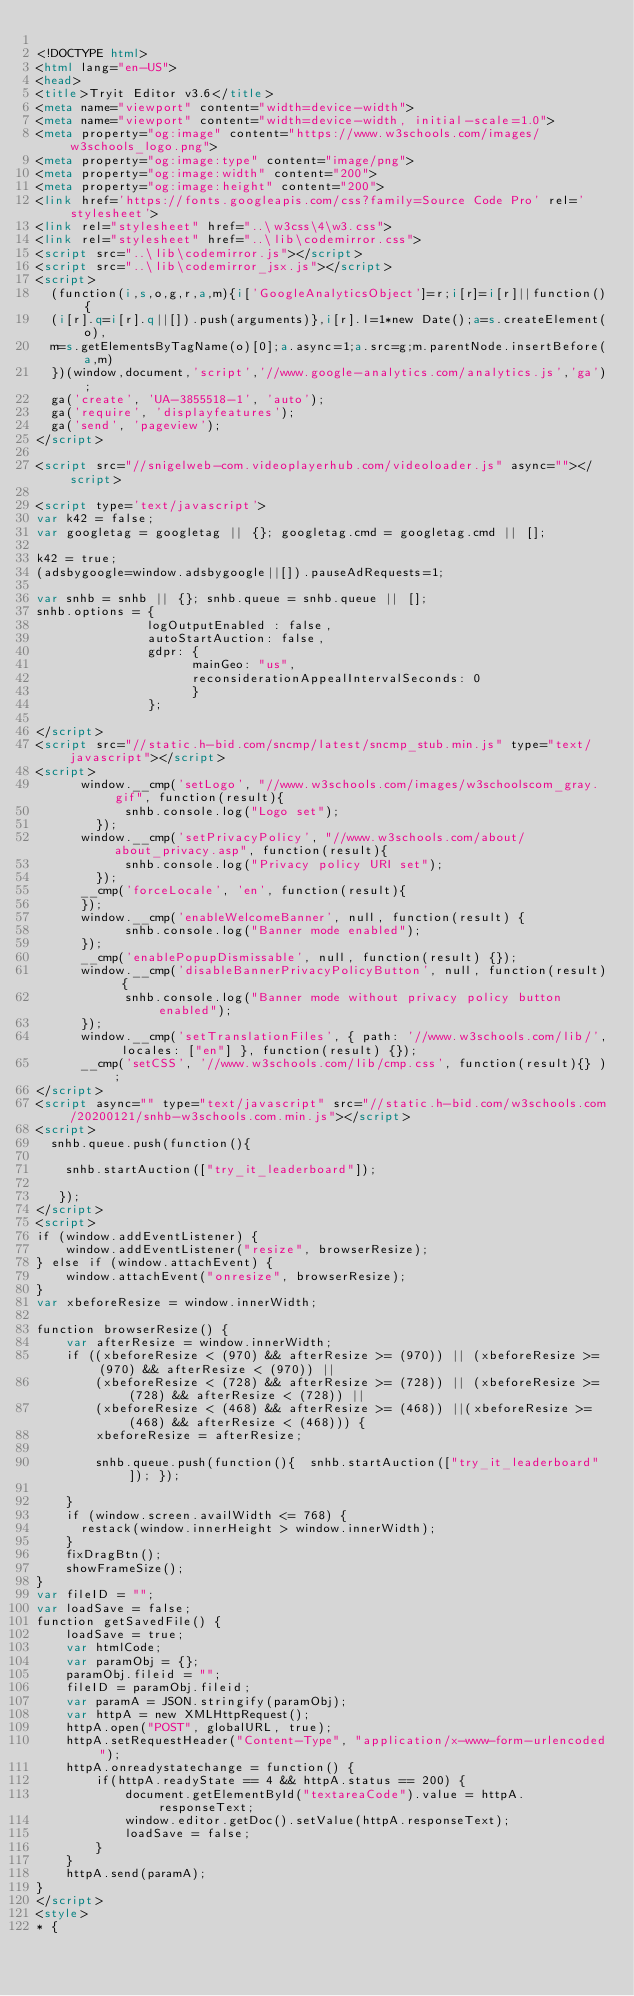<code> <loc_0><loc_0><loc_500><loc_500><_HTML_>
<!DOCTYPE html>
<html lang="en-US">
<head>
<title>Tryit Editor v3.6</title>
<meta name="viewport" content="width=device-width">
<meta name="viewport" content="width=device-width, initial-scale=1.0">
<meta property="og:image" content="https://www.w3schools.com/images/w3schools_logo.png">
<meta property="og:image:type" content="image/png">
<meta property="og:image:width" content="200">
<meta property="og:image:height" content="200">
<link href='https://fonts.googleapis.com/css?family=Source Code Pro' rel='stylesheet'>
<link rel="stylesheet" href="..\w3css\4\w3.css">
<link rel="stylesheet" href="..\lib\codemirror.css">
<script src="..\lib\codemirror.js"></script>
<script src="..\lib\codemirror_jsx.js"></script>
<script>
  (function(i,s,o,g,r,a,m){i['GoogleAnalyticsObject']=r;i[r]=i[r]||function(){
  (i[r].q=i[r].q||[]).push(arguments)},i[r].l=1*new Date();a=s.createElement(o),
  m=s.getElementsByTagName(o)[0];a.async=1;a.src=g;m.parentNode.insertBefore(a,m)
  })(window,document,'script','//www.google-analytics.com/analytics.js','ga');
  ga('create', 'UA-3855518-1', 'auto');
  ga('require', 'displayfeatures');
  ga('send', 'pageview');
</script>

<script src="//snigelweb-com.videoplayerhub.com/videoloader.js" async=""></script>

<script type='text/javascript'>
var k42 = false;
var googletag = googletag || {}; googletag.cmd = googletag.cmd || [];

k42 = true;
(adsbygoogle=window.adsbygoogle||[]).pauseAdRequests=1;

var snhb = snhb || {}; snhb.queue = snhb.queue || [];
snhb.options = {
               logOutputEnabled : false,
               autoStartAuction: false,
               gdpr: {
                     mainGeo: "us",
                     reconsiderationAppealIntervalSeconds: 0
                     }
               };

</script>
<script src="//static.h-bid.com/sncmp/latest/sncmp_stub.min.js" type="text/javascript"></script>
<script>
			window.__cmp('setLogo', "//www.w3schools.com/images/w3schoolscom_gray.gif", function(result){
	       		snhb.console.log("Logo set");
	    	});
			window.__cmp('setPrivacyPolicy', "//www.w3schools.com/about/about_privacy.asp", function(result){
	       		snhb.console.log("Privacy policy URI set");
	    	});
			__cmp('forceLocale', 'en', function(result){
	    });
			window.__cmp('enableWelcomeBanner', null, function(result) {
	       		snhb.console.log("Banner mode enabled");
			});
			__cmp('enablePopupDismissable', null, function(result) {});
			window.__cmp('disableBannerPrivacyPolicyButton', null, function(result) {
	       		snhb.console.log("Banner mode without privacy policy button enabled");
			});
      window.__cmp('setTranslationFiles', { path: '//www.w3schools.com/lib/', locales: ["en"] }, function(result) {});
      __cmp('setCSS', '//www.w3schools.com/lib/cmp.css', function(result){} );
</script>
<script async="" type="text/javascript" src="//static.h-bid.com/w3schools.com/20200121/snhb-w3schools.com.min.js"></script>
<script>
  snhb.queue.push(function(){

    snhb.startAuction(["try_it_leaderboard"]);

   });
</script>
<script>
if (window.addEventListener) {              
    window.addEventListener("resize", browserResize);
} else if (window.attachEvent) {                 
    window.attachEvent("onresize", browserResize);
}
var xbeforeResize = window.innerWidth;

function browserResize() {
    var afterResize = window.innerWidth;
    if ((xbeforeResize < (970) && afterResize >= (970)) || (xbeforeResize >= (970) && afterResize < (970)) ||
        (xbeforeResize < (728) && afterResize >= (728)) || (xbeforeResize >= (728) && afterResize < (728)) ||
        (xbeforeResize < (468) && afterResize >= (468)) ||(xbeforeResize >= (468) && afterResize < (468))) {
        xbeforeResize = afterResize;
        
        snhb.queue.push(function(){  snhb.startAuction(["try_it_leaderboard"]); });
         
    }
    if (window.screen.availWidth <= 768) {
      restack(window.innerHeight > window.innerWidth);
    }
    fixDragBtn();
    showFrameSize();    
}
var fileID = "";
var loadSave = false;
function getSavedFile() {
    loadSave = true;
    var htmlCode;
    var paramObj = {};
    paramObj.fileid = "";
    fileID = paramObj.fileid;
    var paramA = JSON.stringify(paramObj);
    var httpA = new XMLHttpRequest();
    httpA.open("POST", globalURL, true);
    httpA.setRequestHeader("Content-Type", "application/x-www-form-urlencoded");
    httpA.onreadystatechange = function() {
        if(httpA.readyState == 4 && httpA.status == 200) {
            document.getElementById("textareaCode").value = httpA.responseText;
            window.editor.getDoc().setValue(httpA.responseText);
            loadSave = false;
        }
    }
    httpA.send(paramA);   
}
</script>
<style>
* {</code> 